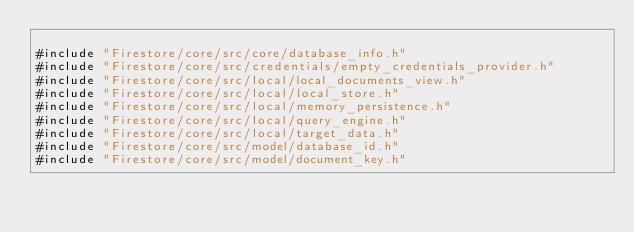<code> <loc_0><loc_0><loc_500><loc_500><_ObjectiveC_>
#include "Firestore/core/src/core/database_info.h"
#include "Firestore/core/src/credentials/empty_credentials_provider.h"
#include "Firestore/core/src/local/local_documents_view.h"
#include "Firestore/core/src/local/local_store.h"
#include "Firestore/core/src/local/memory_persistence.h"
#include "Firestore/core/src/local/query_engine.h"
#include "Firestore/core/src/local/target_data.h"
#include "Firestore/core/src/model/database_id.h"
#include "Firestore/core/src/model/document_key.h"</code> 